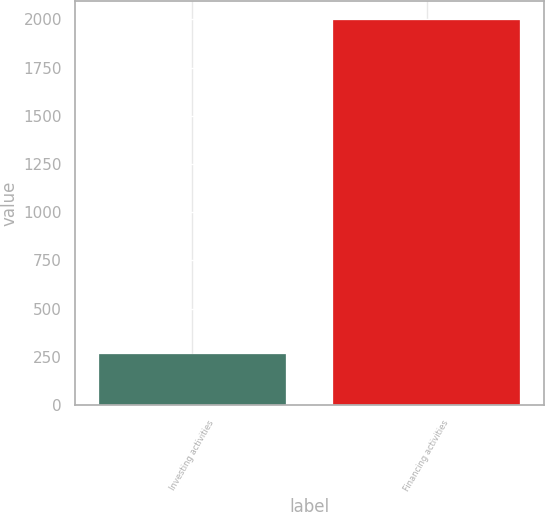Convert chart. <chart><loc_0><loc_0><loc_500><loc_500><bar_chart><fcel>Investing activities<fcel>Financing activities<nl><fcel>266<fcel>1997<nl></chart> 